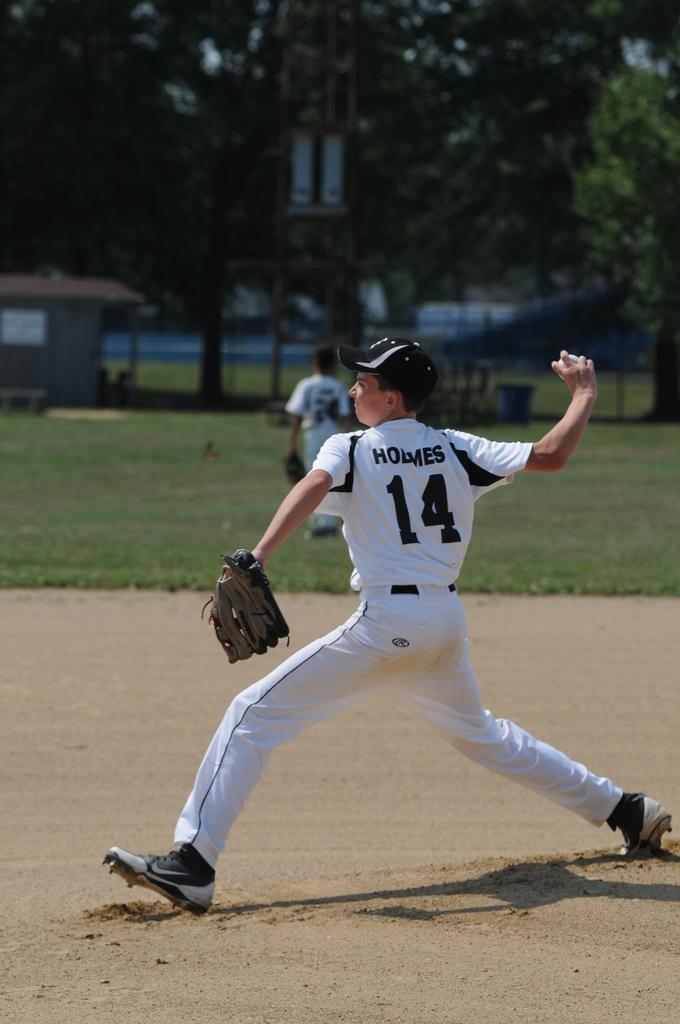<image>
Summarize the visual content of the image. Holmes wears number 14 and is the pitcher on his team. 